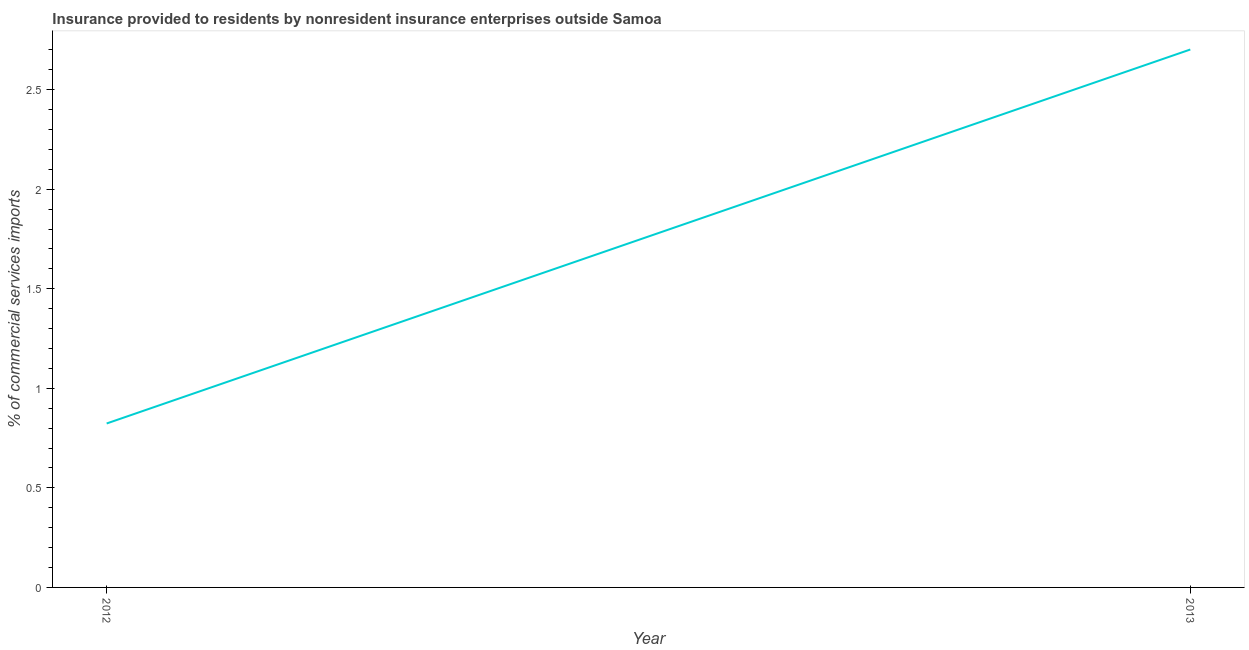What is the insurance provided by non-residents in 2013?
Your response must be concise. 2.7. Across all years, what is the maximum insurance provided by non-residents?
Provide a succinct answer. 2.7. Across all years, what is the minimum insurance provided by non-residents?
Keep it short and to the point. 0.82. In which year was the insurance provided by non-residents minimum?
Keep it short and to the point. 2012. What is the sum of the insurance provided by non-residents?
Give a very brief answer. 3.52. What is the difference between the insurance provided by non-residents in 2012 and 2013?
Provide a short and direct response. -1.88. What is the average insurance provided by non-residents per year?
Keep it short and to the point. 1.76. What is the median insurance provided by non-residents?
Offer a terse response. 1.76. In how many years, is the insurance provided by non-residents greater than 0.9 %?
Make the answer very short. 1. Do a majority of the years between 2013 and 2012 (inclusive) have insurance provided by non-residents greater than 0.2 %?
Keep it short and to the point. No. What is the ratio of the insurance provided by non-residents in 2012 to that in 2013?
Provide a short and direct response. 0.3. Does the insurance provided by non-residents monotonically increase over the years?
Ensure brevity in your answer.  Yes. What is the difference between two consecutive major ticks on the Y-axis?
Your answer should be compact. 0.5. Are the values on the major ticks of Y-axis written in scientific E-notation?
Offer a very short reply. No. Does the graph contain grids?
Make the answer very short. No. What is the title of the graph?
Your answer should be compact. Insurance provided to residents by nonresident insurance enterprises outside Samoa. What is the label or title of the Y-axis?
Ensure brevity in your answer.  % of commercial services imports. What is the % of commercial services imports in 2012?
Provide a succinct answer. 0.82. What is the % of commercial services imports in 2013?
Your answer should be very brief. 2.7. What is the difference between the % of commercial services imports in 2012 and 2013?
Ensure brevity in your answer.  -1.88. What is the ratio of the % of commercial services imports in 2012 to that in 2013?
Your answer should be compact. 0.3. 